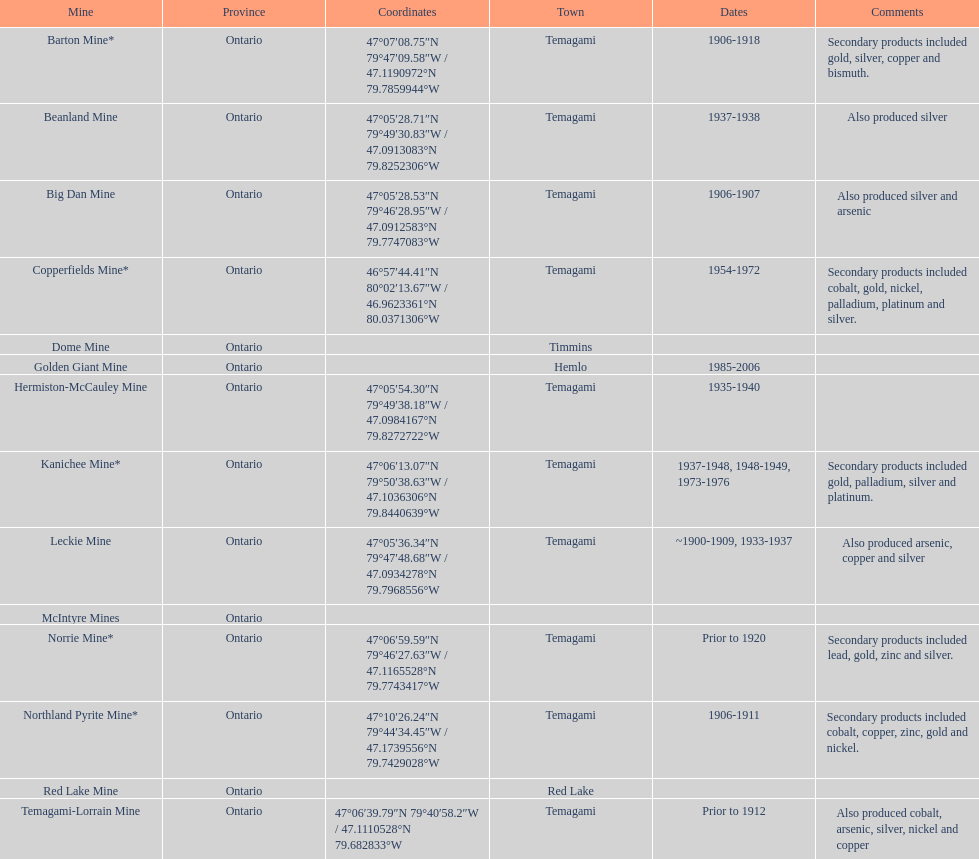Which mine is located in the timmins town? Dome Mine. Would you mind parsing the complete table? {'header': ['Mine', 'Province', 'Coordinates', 'Town', 'Dates', 'Comments'], 'rows': [['Barton Mine*', 'Ontario', '47°07′08.75″N 79°47′09.58″W\ufeff / \ufeff47.1190972°N 79.7859944°W', 'Temagami', '1906-1918', 'Secondary products included gold, silver, copper and bismuth.'], ['Beanland Mine', 'Ontario', '47°05′28.71″N 79°49′30.83″W\ufeff / \ufeff47.0913083°N 79.8252306°W', 'Temagami', '1937-1938', 'Also produced silver'], ['Big Dan Mine', 'Ontario', '47°05′28.53″N 79°46′28.95″W\ufeff / \ufeff47.0912583°N 79.7747083°W', 'Temagami', '1906-1907', 'Also produced silver and arsenic'], ['Copperfields Mine*', 'Ontario', '46°57′44.41″N 80°02′13.67″W\ufeff / \ufeff46.9623361°N 80.0371306°W', 'Temagami', '1954-1972', 'Secondary products included cobalt, gold, nickel, palladium, platinum and silver.'], ['Dome Mine', 'Ontario', '', 'Timmins', '', ''], ['Golden Giant Mine', 'Ontario', '', 'Hemlo', '1985-2006', ''], ['Hermiston-McCauley Mine', 'Ontario', '47°05′54.30″N 79°49′38.18″W\ufeff / \ufeff47.0984167°N 79.8272722°W', 'Temagami', '1935-1940', ''], ['Kanichee Mine*', 'Ontario', '47°06′13.07″N 79°50′38.63″W\ufeff / \ufeff47.1036306°N 79.8440639°W', 'Temagami', '1937-1948, 1948-1949, 1973-1976', 'Secondary products included gold, palladium, silver and platinum.'], ['Leckie Mine', 'Ontario', '47°05′36.34″N 79°47′48.68″W\ufeff / \ufeff47.0934278°N 79.7968556°W', 'Temagami', '~1900-1909, 1933-1937', 'Also produced arsenic, copper and silver'], ['McIntyre Mines', 'Ontario', '', '', '', ''], ['Norrie Mine*', 'Ontario', '47°06′59.59″N 79°46′27.63″W\ufeff / \ufeff47.1165528°N 79.7743417°W', 'Temagami', 'Prior to 1920', 'Secondary products included lead, gold, zinc and silver.'], ['Northland Pyrite Mine*', 'Ontario', '47°10′26.24″N 79°44′34.45″W\ufeff / \ufeff47.1739556°N 79.7429028°W', 'Temagami', '1906-1911', 'Secondary products included cobalt, copper, zinc, gold and nickel.'], ['Red Lake Mine', 'Ontario', '', 'Red Lake', '', ''], ['Temagami-Lorrain Mine', 'Ontario', '47°06′39.79″N 79°40′58.2″W\ufeff / \ufeff47.1110528°N 79.682833°W', 'Temagami', 'Prior to 1912', 'Also produced cobalt, arsenic, silver, nickel and copper']]} 